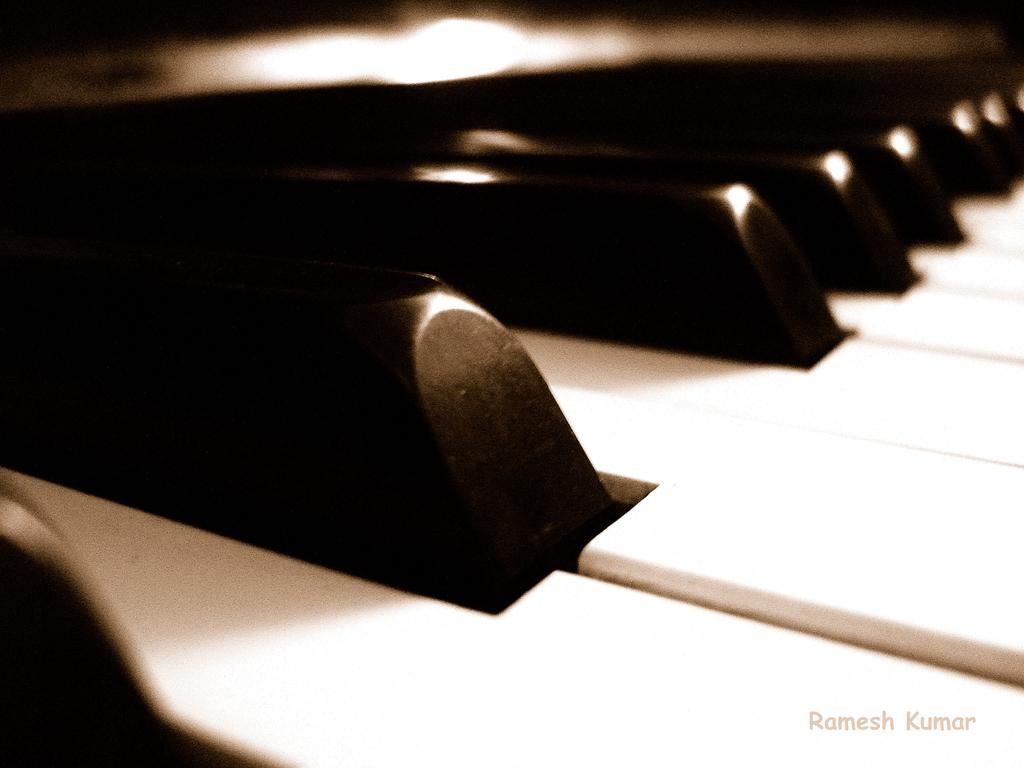What can be seen in the image related to a musical instrument? There are piano keys in the image. What type of skin condition is visible on the piano keys in the image? There is no skin condition visible on the piano keys in the image, as they are not a living organism. 